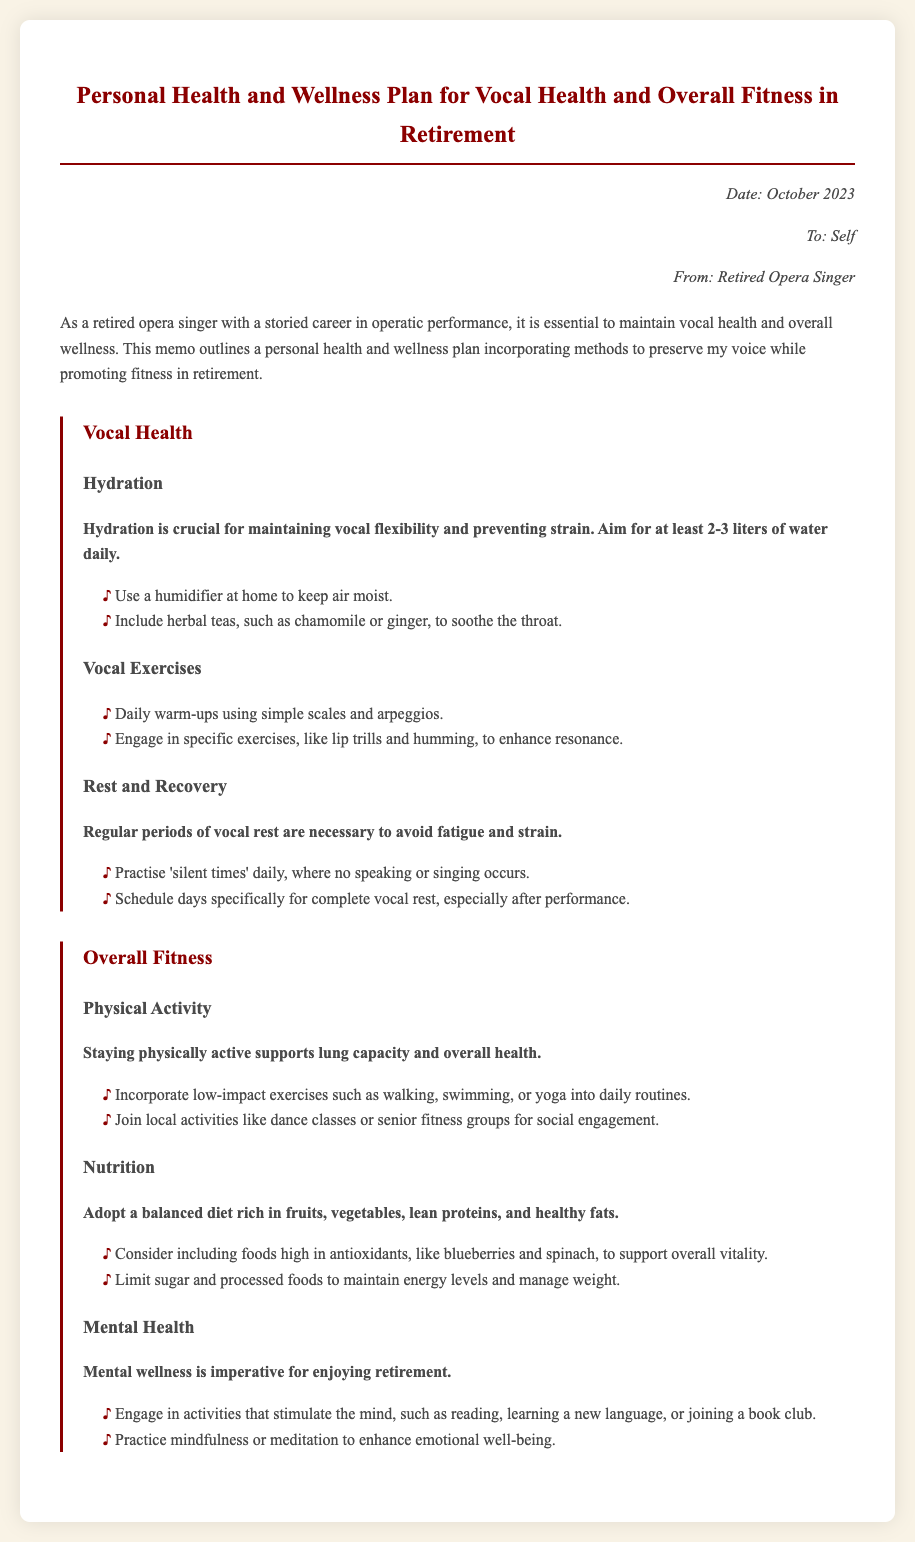What is the main focus of the memo? The memo outlines a personal health and wellness plan for maintaining vocal health and overall fitness in retirement.
Answer: Personal health and wellness plan How much water should one aim to drink daily? The document states that one should aim for at least 2-3 liters of water daily to maintain vocal flexibility.
Answer: 2-3 liters What exercises are suggested for vocal warm-ups? The memo lists daily warm-ups using simple scales and arpeggios as part of vocal exercises.
Answer: Simple scales and arpeggios What type of nutrition is recommended? The document emphasizes adopting a balanced diet rich in fruits, vegetables, lean proteins, and healthy fats.
Answer: Balanced diet What activities can support mental wellness? The memo suggests engaging in activities that stimulate the mind, such as reading, learning a new language, or joining a book club.
Answer: Reading, learning a new language, or joining a book club What is the significance of hydration for vocal health? The document highlights that hydration is crucial for maintaining vocal flexibility and preventing strain.
Answer: Maintaining vocal flexibility How often should one schedule complete vocal rest? The memo recommends scheduling days specifically for complete vocal rest, especially after performance.
Answer: Days specifically for complete vocal rest What types of physical activity are suggested? The document recommends incorporating low-impact exercises such as walking, swimming, or yoga into daily routines.
Answer: Walking, swimming, or yoga 